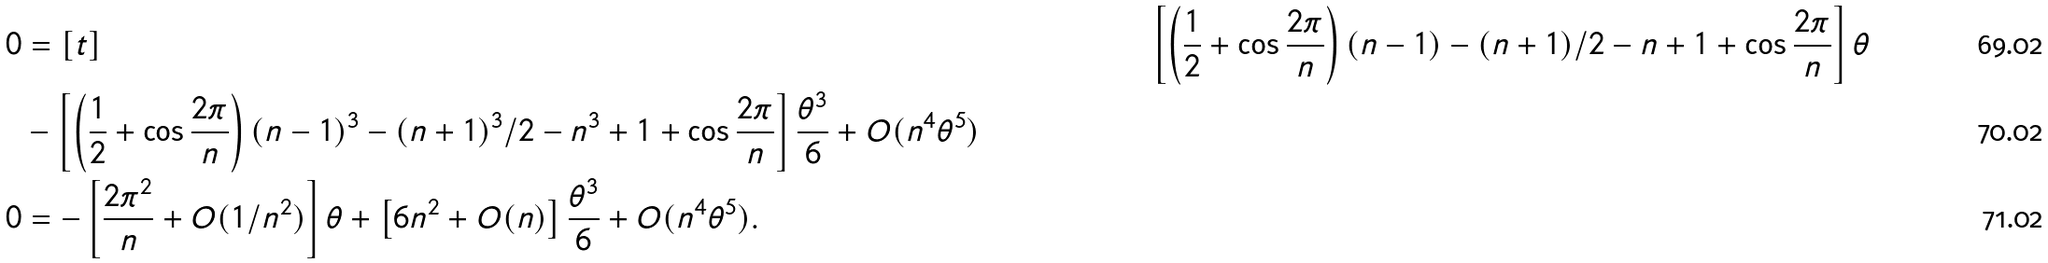Convert formula to latex. <formula><loc_0><loc_0><loc_500><loc_500>0 & = [ t ] & \left [ \left ( \frac { 1 } { 2 } + \cos \frac { 2 \pi } { n } \right ) ( n - 1 ) - ( n + 1 ) / 2 - n + 1 + \cos \frac { 2 \pi } { n } \right ] \theta \\ & - \left [ \left ( \frac { 1 } { 2 } + \cos \frac { 2 \pi } { n } \right ) ( n - 1 ) ^ { 3 } - ( n + 1 ) ^ { 3 } / 2 - n ^ { 3 } + 1 + \cos \frac { 2 \pi } { n } \right ] \frac { \theta ^ { 3 } } { 6 } + O ( n ^ { 4 } \theta ^ { 5 } ) \\ 0 & = - \left [ \frac { 2 \pi ^ { 2 } } { n } + O ( 1 / n ^ { 2 } ) \right ] \theta + \left [ 6 n ^ { 2 } + O ( n ) \right ] \frac { \theta ^ { 3 } } { 6 } + O ( n ^ { 4 } \theta ^ { 5 } ) .</formula> 